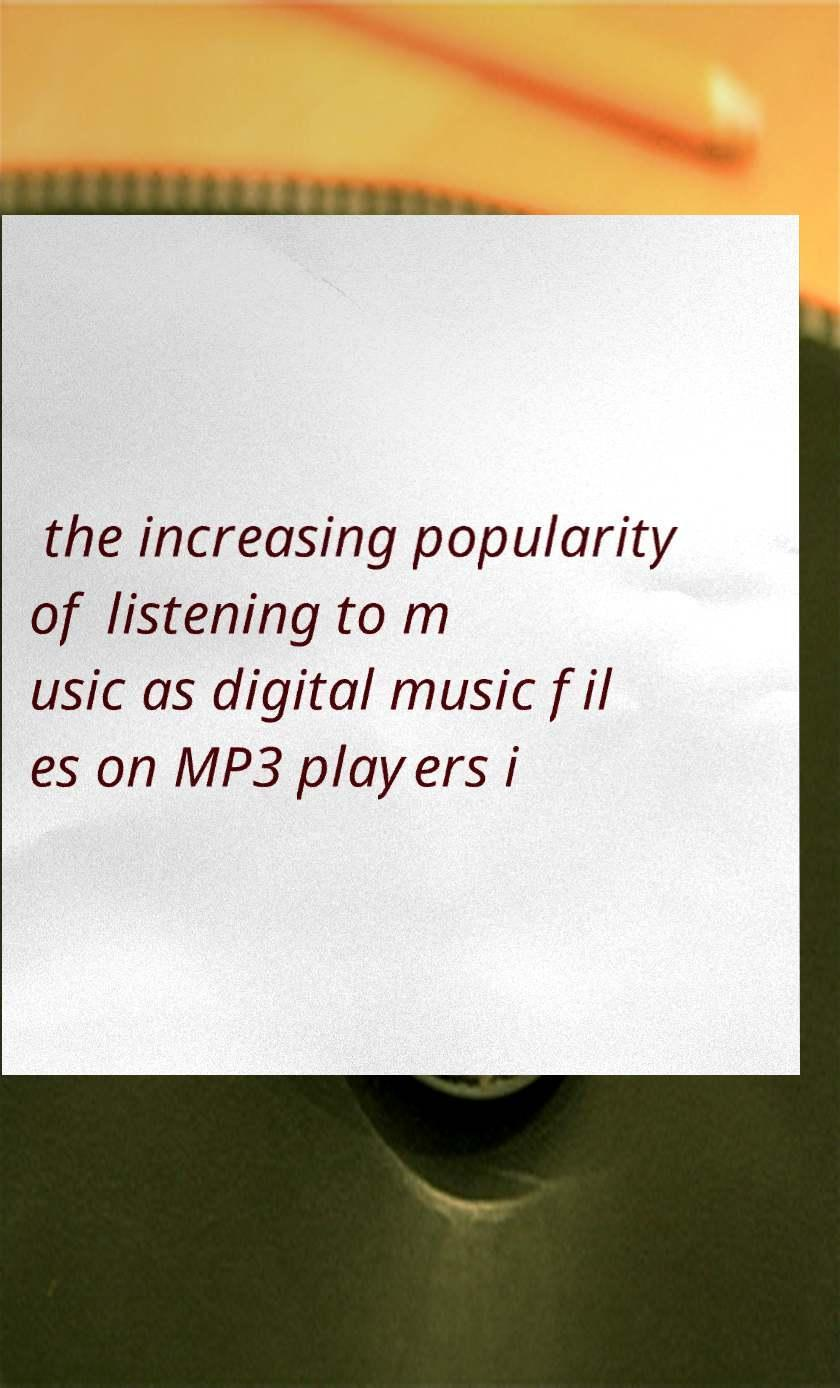Can you read and provide the text displayed in the image?This photo seems to have some interesting text. Can you extract and type it out for me? the increasing popularity of listening to m usic as digital music fil es on MP3 players i 